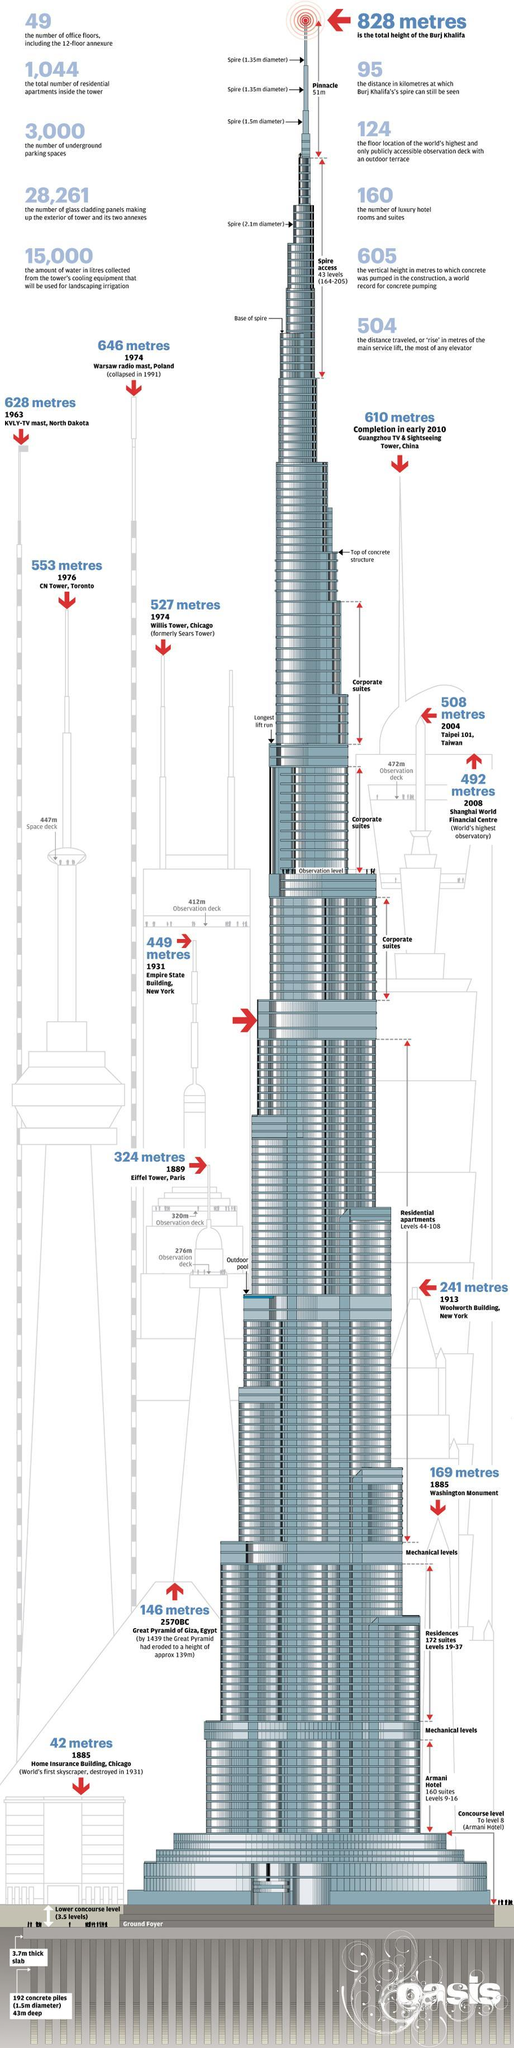Point out several critical features in this image. The height of Willis Tower in Chicago is 527 meters. Burj Khalifa has 172 residential suites located on levels 19-37, spread across 37 floors. The Burj Khalifa's Armani Hotel occupies floors 9 through 16. The total number of residential apartments in the tower is 1,044. Burj Khalifa has approximately 3,000 underground parking spaces available. 